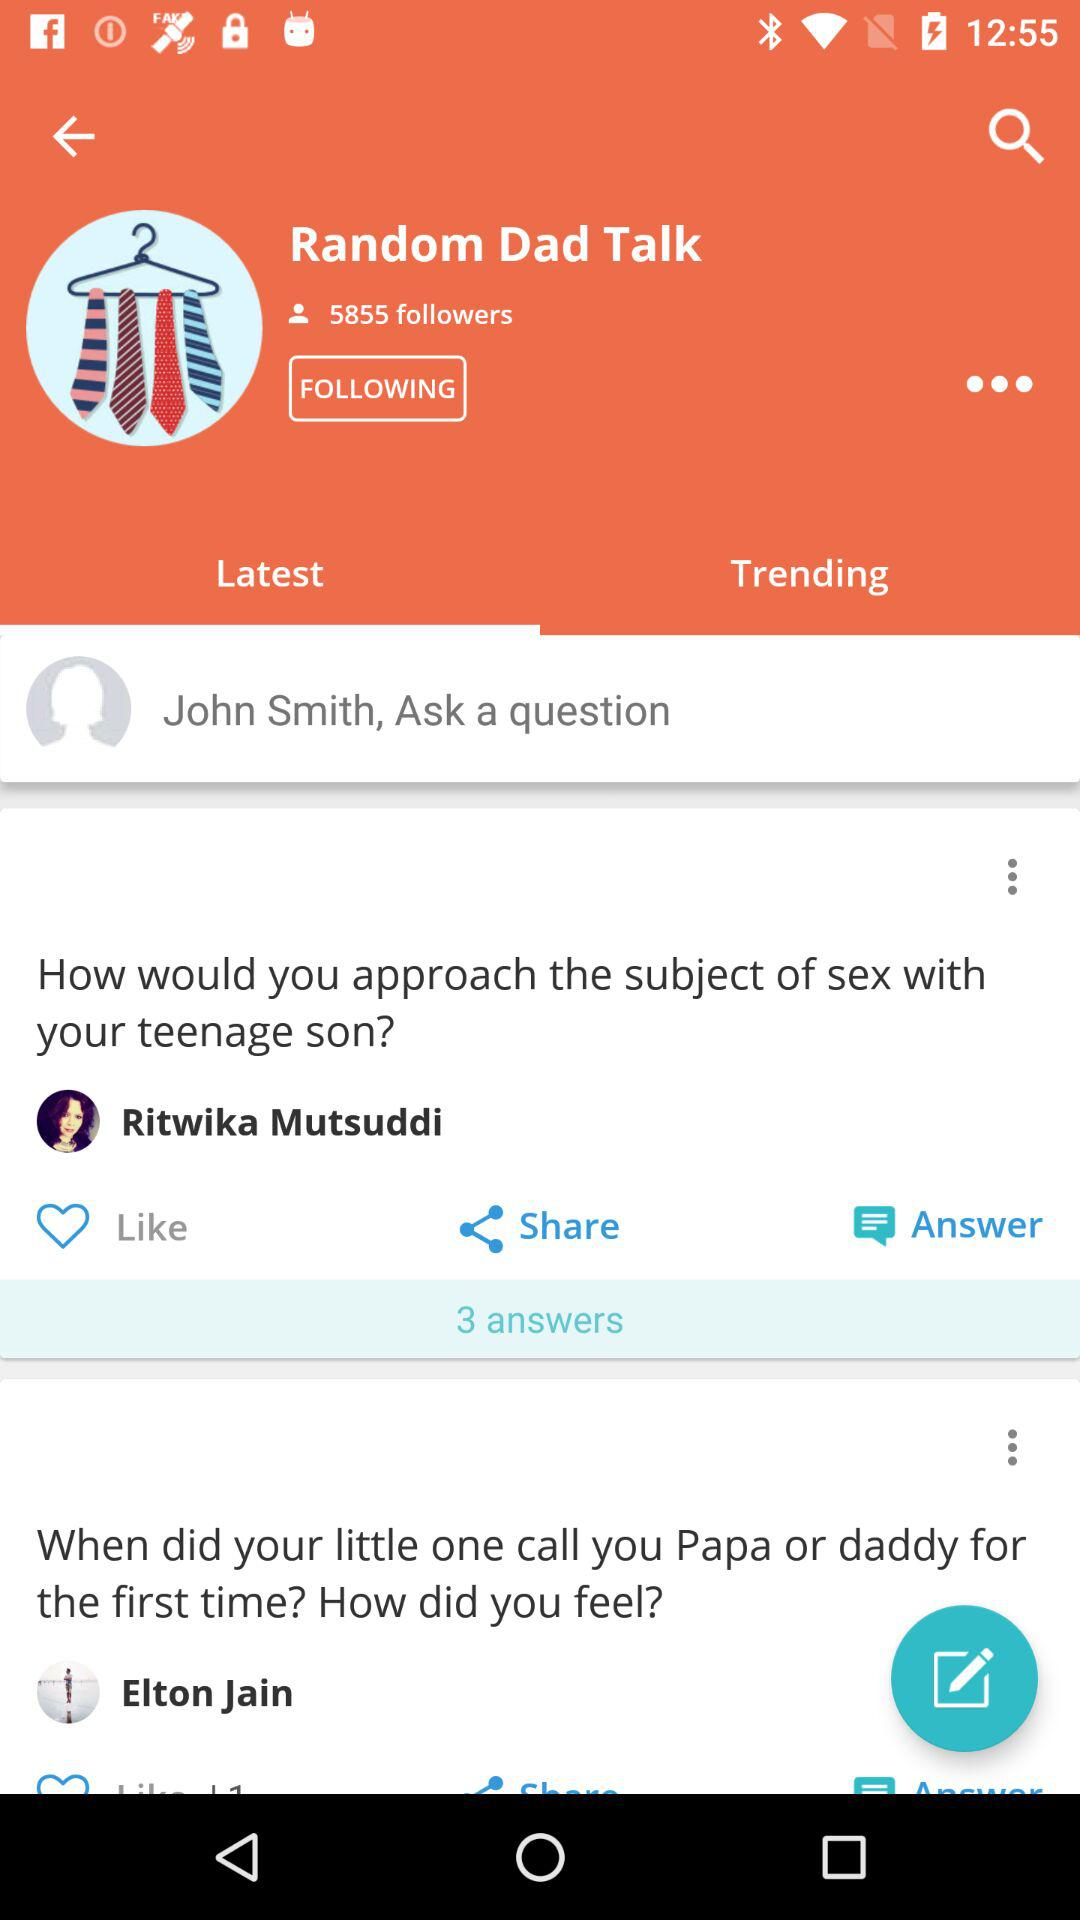Which tab has been selected? The tab that has been selected is "Latest". 